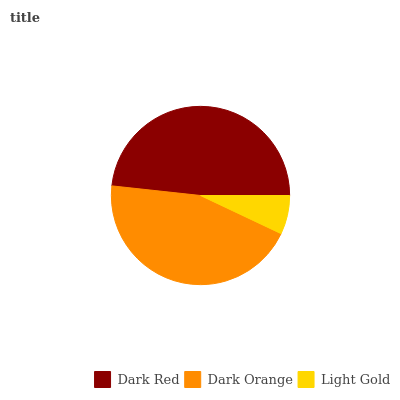Is Light Gold the minimum?
Answer yes or no. Yes. Is Dark Red the maximum?
Answer yes or no. Yes. Is Dark Orange the minimum?
Answer yes or no. No. Is Dark Orange the maximum?
Answer yes or no. No. Is Dark Red greater than Dark Orange?
Answer yes or no. Yes. Is Dark Orange less than Dark Red?
Answer yes or no. Yes. Is Dark Orange greater than Dark Red?
Answer yes or no. No. Is Dark Red less than Dark Orange?
Answer yes or no. No. Is Dark Orange the high median?
Answer yes or no. Yes. Is Dark Orange the low median?
Answer yes or no. Yes. Is Dark Red the high median?
Answer yes or no. No. Is Light Gold the low median?
Answer yes or no. No. 